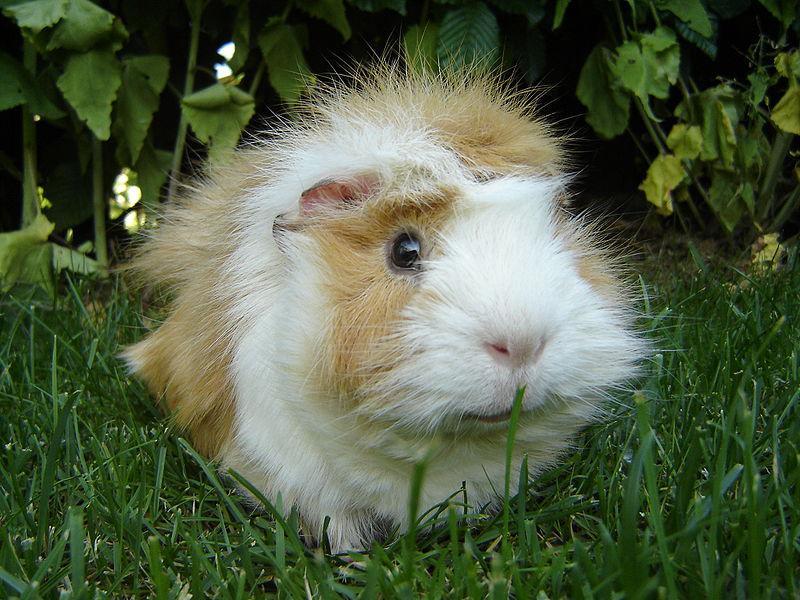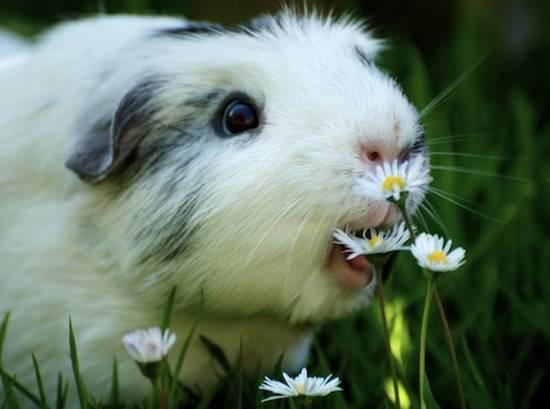The first image is the image on the left, the second image is the image on the right. Given the left and right images, does the statement "the image on the right contains a flower" hold true? Answer yes or no. Yes. 